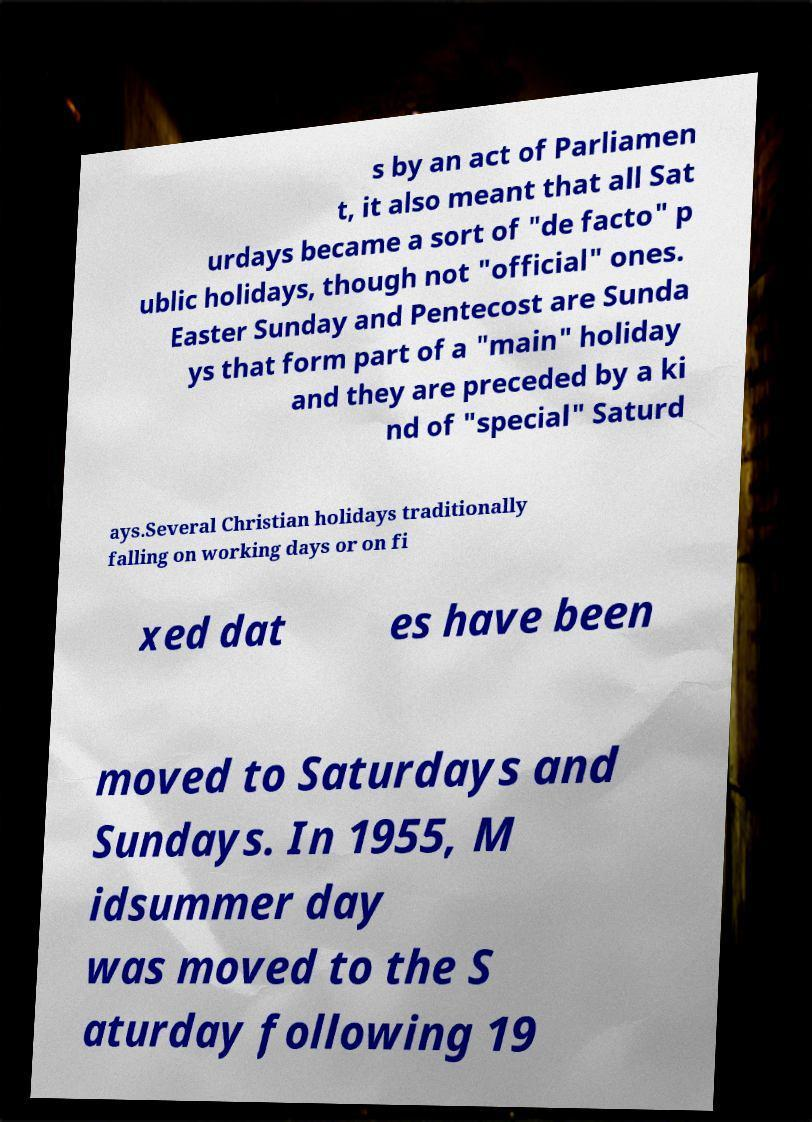Please identify and transcribe the text found in this image. s by an act of Parliamen t, it also meant that all Sat urdays became a sort of "de facto" p ublic holidays, though not "official" ones. Easter Sunday and Pentecost are Sunda ys that form part of a "main" holiday and they are preceded by a ki nd of "special" Saturd ays.Several Christian holidays traditionally falling on working days or on fi xed dat es have been moved to Saturdays and Sundays. In 1955, M idsummer day was moved to the S aturday following 19 